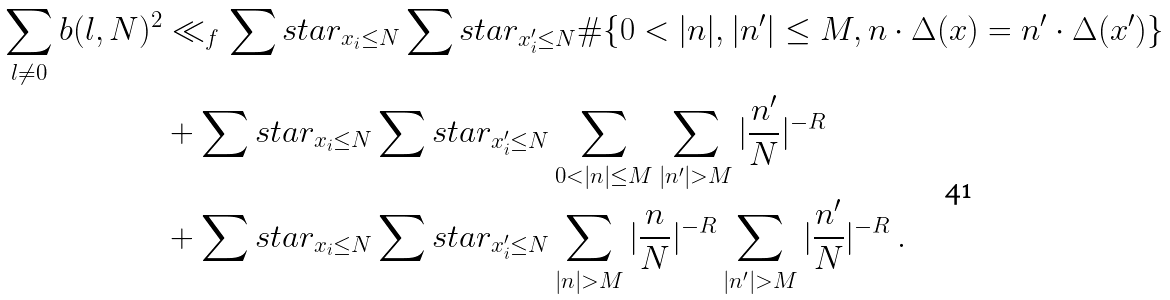Convert formula to latex. <formula><loc_0><loc_0><loc_500><loc_500>\sum _ { l \neq 0 } b ( l , N ) ^ { 2 } & \ll _ { f } \sum s t a r _ { x _ { i } \leq N } \sum s t a r _ { x ^ { \prime } _ { i } \leq N } \# \{ 0 < | n | , | n ^ { \prime } | \leq M , n \cdot \Delta ( x ) = n ^ { \prime } \cdot \Delta ( x ^ { \prime } ) \} \\ & + \sum s t a r _ { x _ { i } \leq N } \sum s t a r _ { x ^ { \prime } _ { i } \leq N } \sum _ { 0 < | n | \leq M } \sum _ { | n ^ { \prime } | > M } | \frac { n ^ { \prime } } N | ^ { - R } \\ & + \sum s t a r _ { x _ { i } \leq N } \sum s t a r _ { x ^ { \prime } _ { i } \leq N } \sum _ { | n | > M } | \frac { n } N | ^ { - R } \sum _ { | n ^ { \prime } | > M } | \frac { n ^ { \prime } } N | ^ { - R } \, .</formula> 